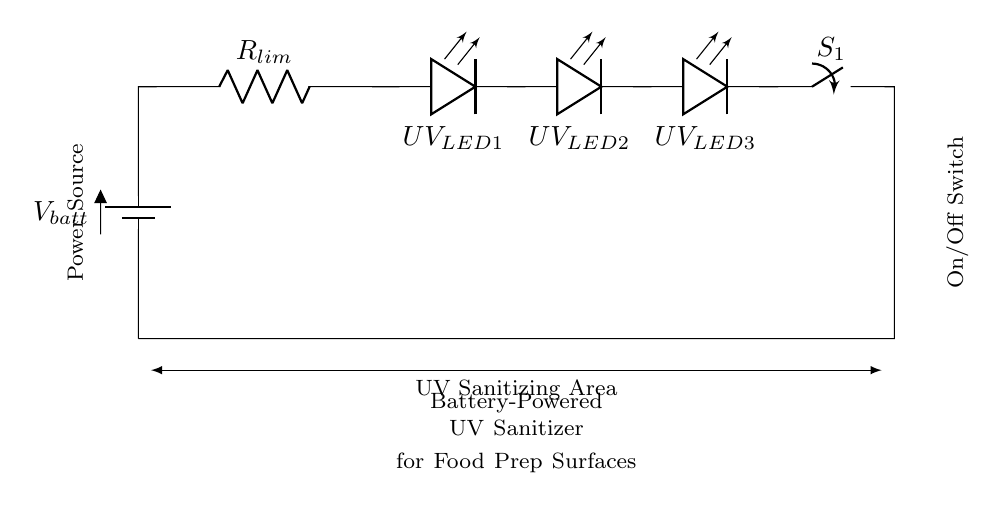What type of circuit is this? The circuit is a series circuit, where all components are connected in a single path. This can be identified by the sequential arrangement of the components from the battery through the resistor and LEDs to the switch.
Answer: Series circuit How many UV LEDs are present in the circuit? There are three UV LEDs shown in the circuit diagram. This is easily counted by identifying the visual representation of the LED components connected in a line.
Answer: Three What is the purpose of the resistor in this circuit? The resistor, labeled as R limiting, is used to limit the current flowing through the UV LEDs. This is important to prevent them from drawing too much current and potentially burning out.
Answer: Limit current What happens when switch S1 is closed? When switch S1 is closed, the circuit is completed, allowing current to flow from the battery through the resistor and UV LEDs. This means all connected components will function, and the UV LEDs will turn on.
Answer: LEDs turn on What is the function of the battery in this circuit? The battery serves as the power source for the circuit, providing the necessary voltage to operate all components. The battery voltage drives the current through the entire series of connected elements.
Answer: Power source What is the significance of series connection for UV LEDs? The series connection means that the same current flows through each UV LED, which is critical for ensuring that all LEDs operate uniformly, creating a consistent UV output for sanitization.
Answer: Uniform current What marks indicate the UV sanitizing area? The arrow marks indicate the UV sanitizing area, suggesting that this is where the ultraviolet light will effectively be used to sanitize food prep surfaces. This is highlighted visually by the connection and placement of LEDs above that area.
Answer: Arrow marks 